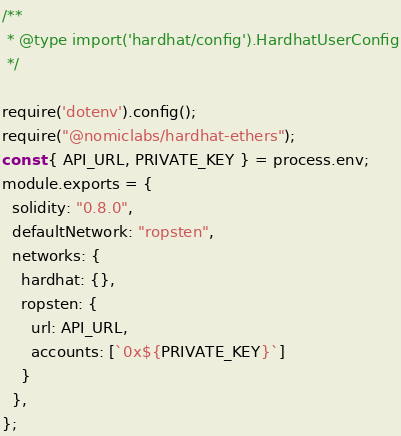<code> <loc_0><loc_0><loc_500><loc_500><_JavaScript_>/**
 * @type import('hardhat/config').HardhatUserConfig
 */

require('dotenv').config();
require("@nomiclabs/hardhat-ethers");
const { API_URL, PRIVATE_KEY } = process.env;
module.exports = {
  solidity: "0.8.0",
  defaultNetwork: "ropsten",
  networks: {
    hardhat: {},
    ropsten: {
      url: API_URL,
      accounts: [`0x${PRIVATE_KEY}`]
    }
  },
};
</code> 